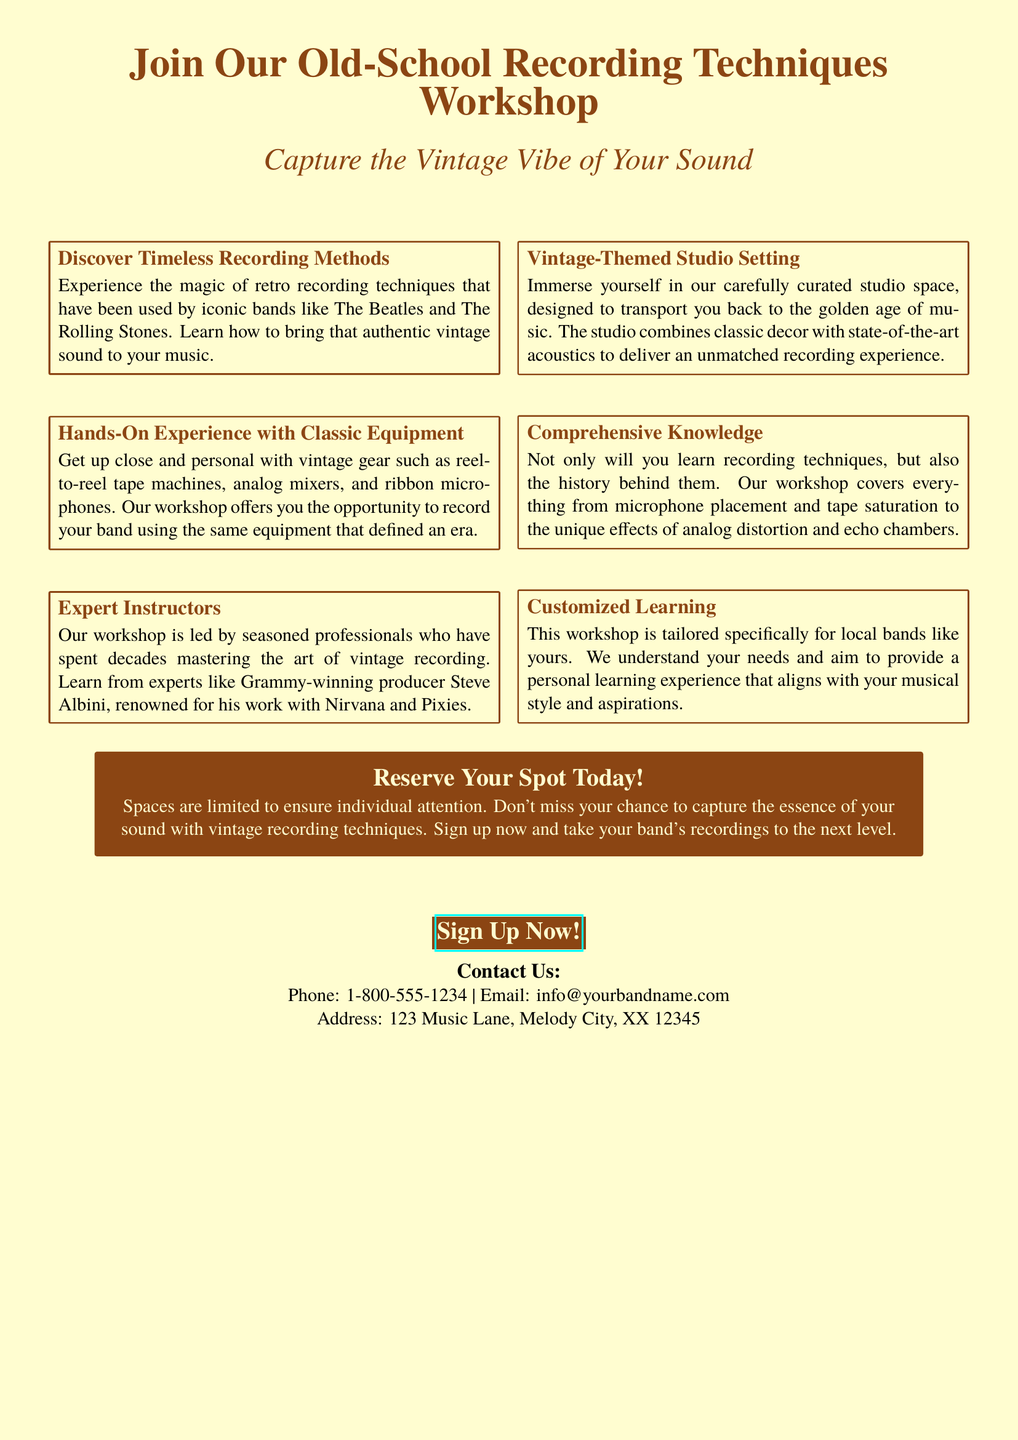What is the title of the workshop? The title is prominently displayed at the beginning of the document.
Answer: Join Our Old-School Recording Techniques Workshop Who is one of the expert instructors mentioned? The document lists Grammy-winning producer Steve Albini as an expert instructor.
Answer: Steve Albini What is the maximum number of participants for the workshop? The document states that spaces are limited but does not specify the exact number, indicating it is designed for individual attention.
Answer: Limited What type of equipment will participants experience? The document mentions vintage gear, specifically naming some types of equipment used in the workshop.
Answer: Reel-to-reel tape machines, analog mixers, ribbon microphones What aspect of history does the workshop cover? The document indicates that the workshop covers the history behind recording techniques as well as their practical application.
Answer: History behind recording techniques What is the location of the workshop? The document provides a specific address where the workshop is held.
Answer: 123 Music Lane, Melody City, XX 12345 What color theme is the document designed with? The color theme is consistently referenced throughout the document, which uses specific hues.
Answer: Vintage brown and vintage cream What should participants do to reserve their spot? The document advises taking immediate action to secure a spot in the workshop.
Answer: Sign up now 